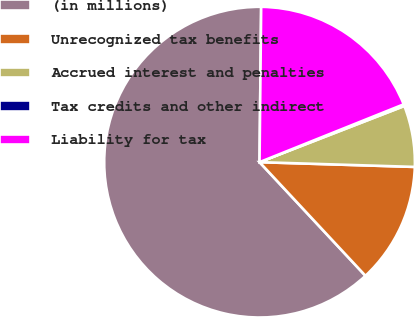<chart> <loc_0><loc_0><loc_500><loc_500><pie_chart><fcel>(in millions)<fcel>Unrecognized tax benefits<fcel>Accrued interest and penalties<fcel>Tax credits and other indirect<fcel>Liability for tax<nl><fcel>62.11%<fcel>12.57%<fcel>6.38%<fcel>0.18%<fcel>18.76%<nl></chart> 